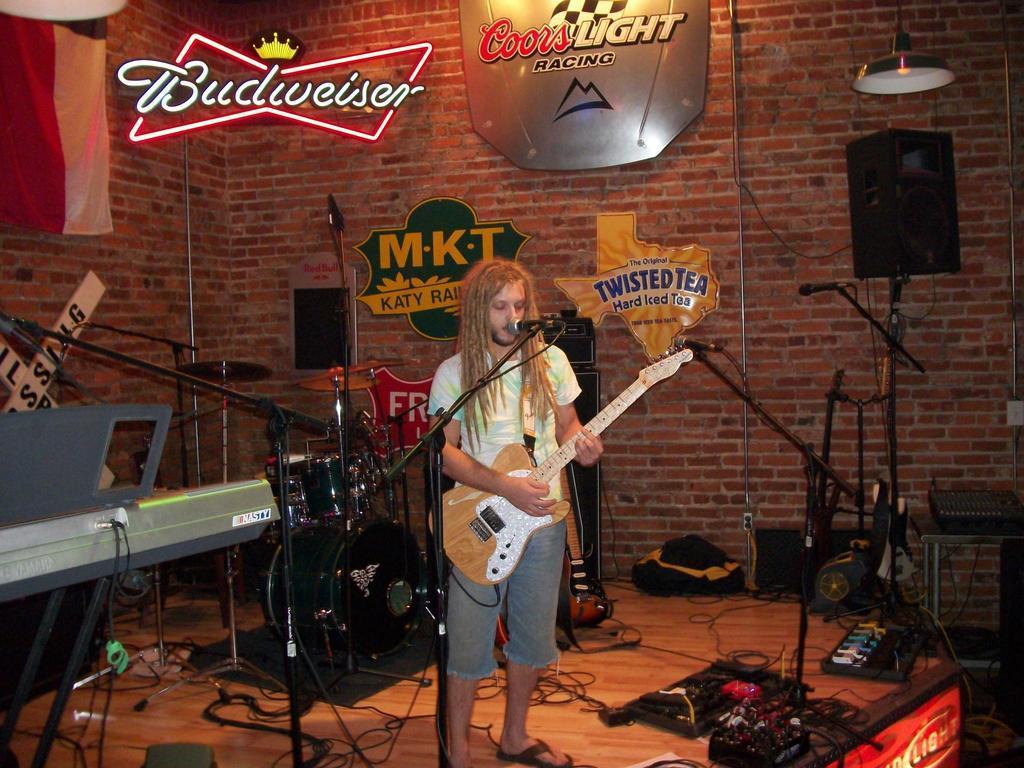Describe this image in one or two sentences. In this picture we can see a man is standing and playing a guitar, there are some microphones in the middle, on the left side there is a piano, on the right side there is a speaker, we can see cymbals and drums in the middle, at the bottom there are some wires and a bag, in the background we can see a wall, a light and some boards, we can see some text on these boards. 